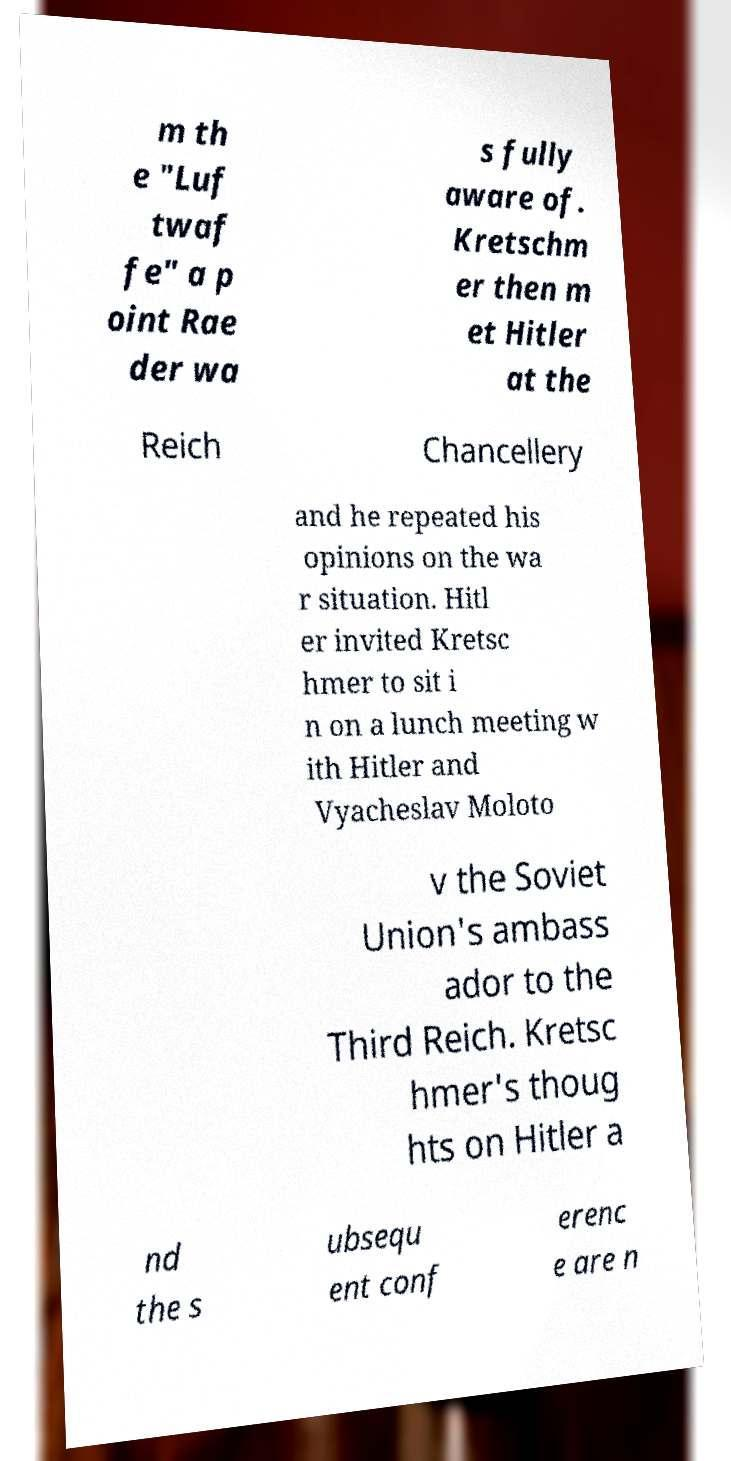For documentation purposes, I need the text within this image transcribed. Could you provide that? m th e "Luf twaf fe" a p oint Rae der wa s fully aware of. Kretschm er then m et Hitler at the Reich Chancellery and he repeated his opinions on the wa r situation. Hitl er invited Kretsc hmer to sit i n on a lunch meeting w ith Hitler and Vyacheslav Moloto v the Soviet Union's ambass ador to the Third Reich. Kretsc hmer's thoug hts on Hitler a nd the s ubsequ ent conf erenc e are n 